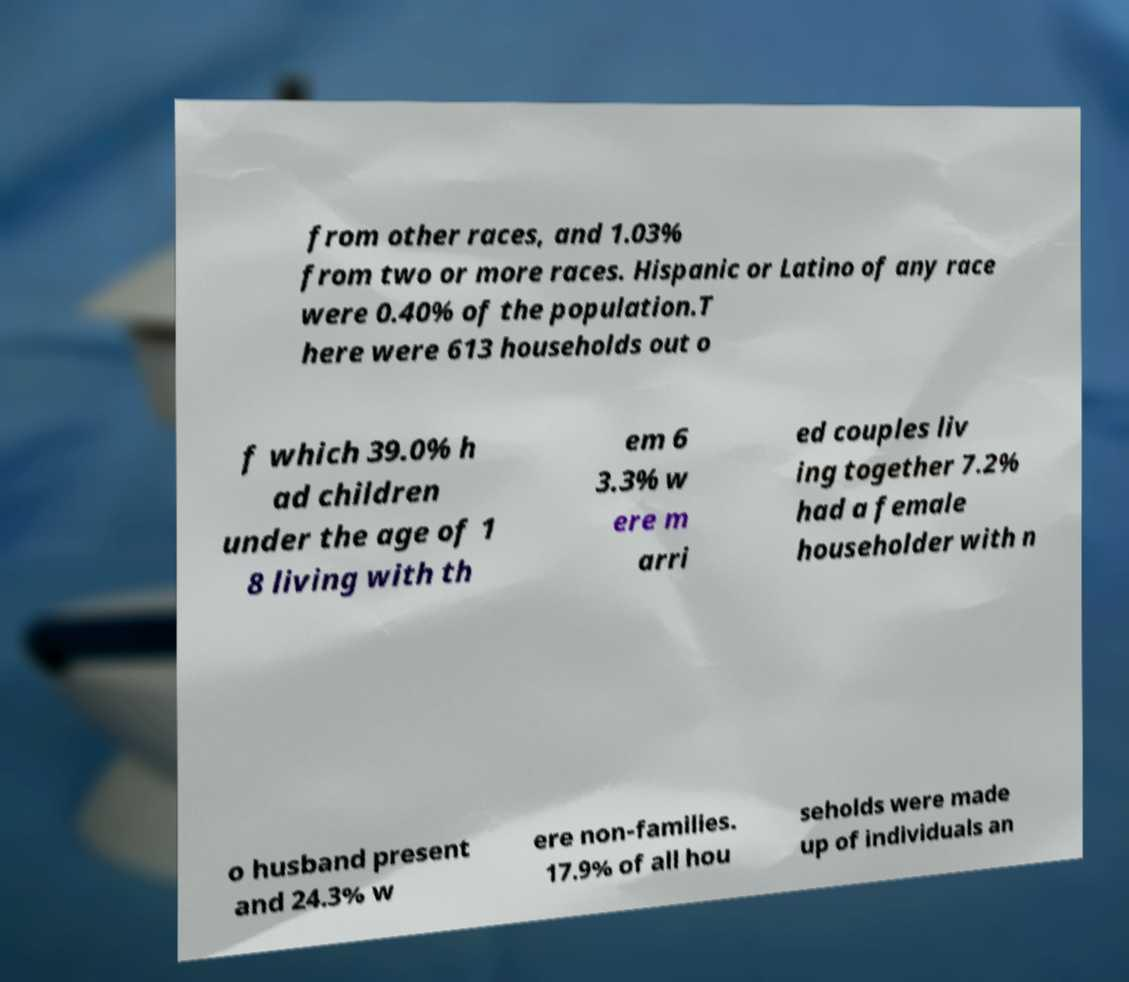Please read and relay the text visible in this image. What does it say? from other races, and 1.03% from two or more races. Hispanic or Latino of any race were 0.40% of the population.T here were 613 households out o f which 39.0% h ad children under the age of 1 8 living with th em 6 3.3% w ere m arri ed couples liv ing together 7.2% had a female householder with n o husband present and 24.3% w ere non-families. 17.9% of all hou seholds were made up of individuals an 